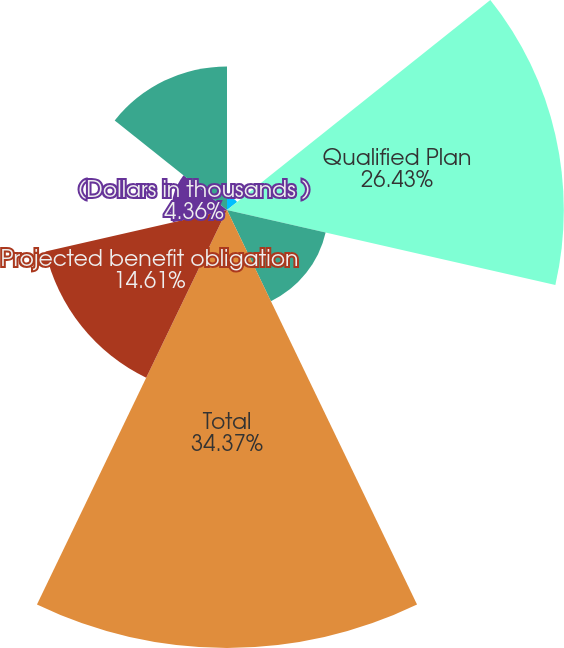<chart> <loc_0><loc_0><loc_500><loc_500><pie_chart><fcel>(Dollars in thousands)<fcel>Qualified Plan<fcel>Non-qualified Plan<fcel>Total<fcel>Projected benefit obligation<fcel>(Dollars in thousands )<fcel>Accumulated benefit obligation<nl><fcel>1.02%<fcel>26.43%<fcel>7.94%<fcel>34.37%<fcel>14.61%<fcel>4.36%<fcel>11.27%<nl></chart> 